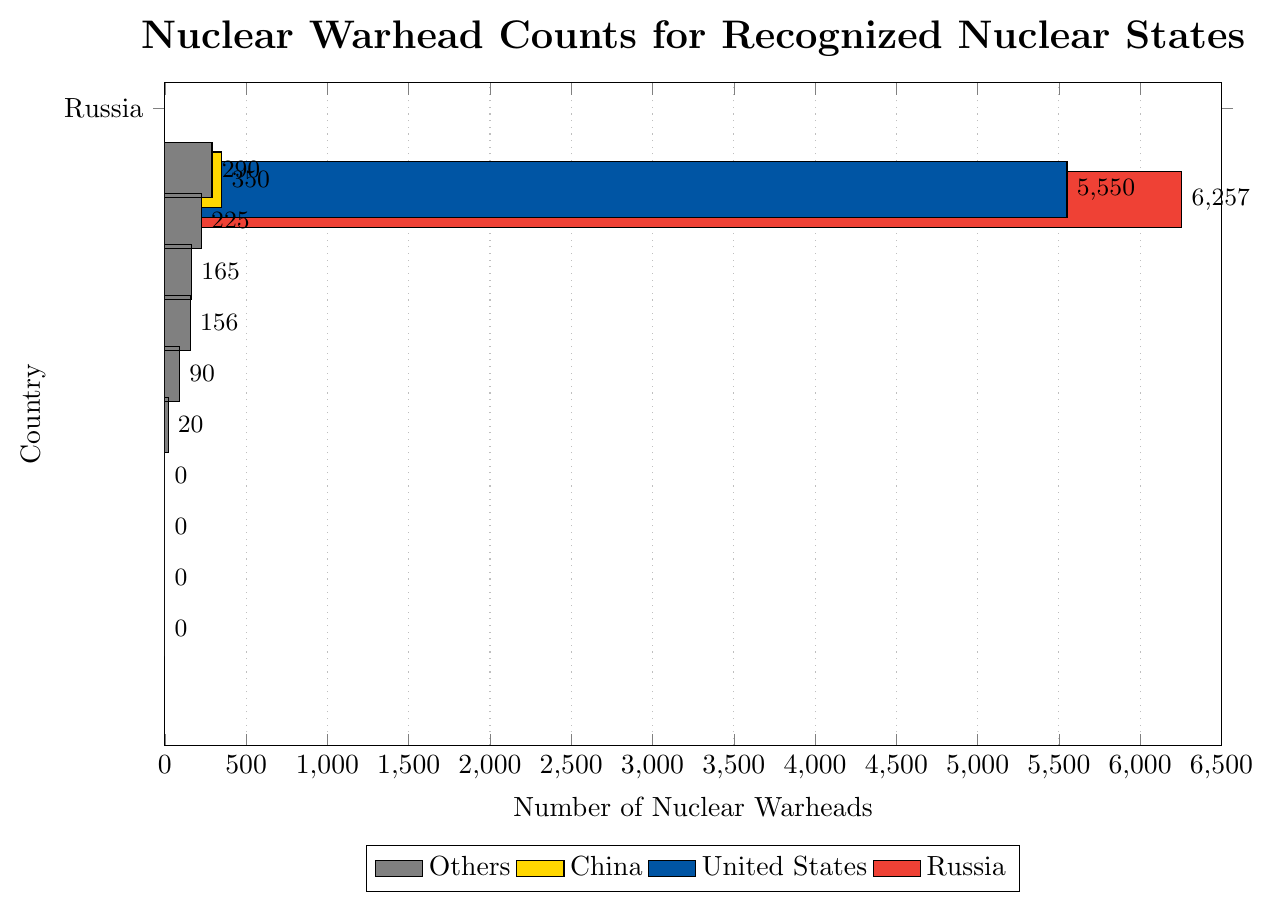Which country has the highest number of nuclear warheads? Russia's bar is the longest, reaching 6257 nuclear warheads.
Answer: Russia Which country has slightly fewer than 6000 nuclear warheads? The second longest bar representing the United States reaches 5550 nuclear warheads.
Answer: United States How many more nuclear warheads does Russia have compared to China? The length difference between Russia's 6257 warheads and China's 350 warheads is 6257 - 350 = 5907.
Answer: 5907 What is the total number of nuclear warheads for France, the United Kingdom, Pakistan, and India combined? Adding the respective counts of 290 (France), 225 (United Kingdom), 165 (Pakistan), and 156 (India) results in 290 + 225 + 165 + 156 = 836.
Answer: 836 Which color represents China in the plot? The bar for China is represented by yellow.
Answer: Yellow Are there any countries with zero nuclear warheads? If yes, how many? Three countries have bars at zero: South Africa, Ukraine, Belarus, and Kazakhstan.
Answer: Three Which two countries have the smallest counts of nuclear warheads and what are their counts? Israel has 90 warheads and North Korea has 20 warheads.
Answer: Israel (90), North Korea (20) How many nuclear warheads do the countries with gray bars collectively have? Summing the warheads of France (290), United Kingdom (225), Pakistan (165), India (156), Israel (90), North Korea (20), South Africa (0), Ukraine (0), Belarus (0), and Kazakhstan (0) gives 290 + 225 + 165 + 156 + 90 + 20 + 0 + 0 + 0 + 0 = 946.
Answer: 946 